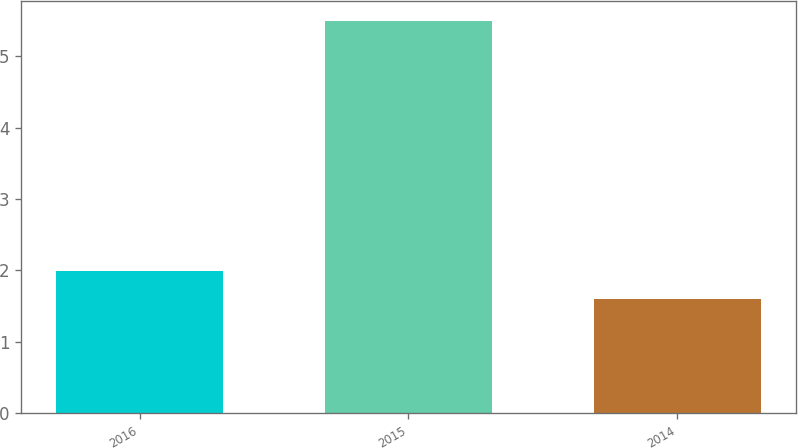Convert chart to OTSL. <chart><loc_0><loc_0><loc_500><loc_500><bar_chart><fcel>2016<fcel>2015<fcel>2014<nl><fcel>1.99<fcel>5.5<fcel>1.6<nl></chart> 